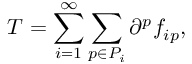<formula> <loc_0><loc_0><loc_500><loc_500>T = \sum _ { i = 1 } ^ { \infty } \sum _ { p \in P _ { i } } \partial ^ { p } f _ { i p } ,</formula> 